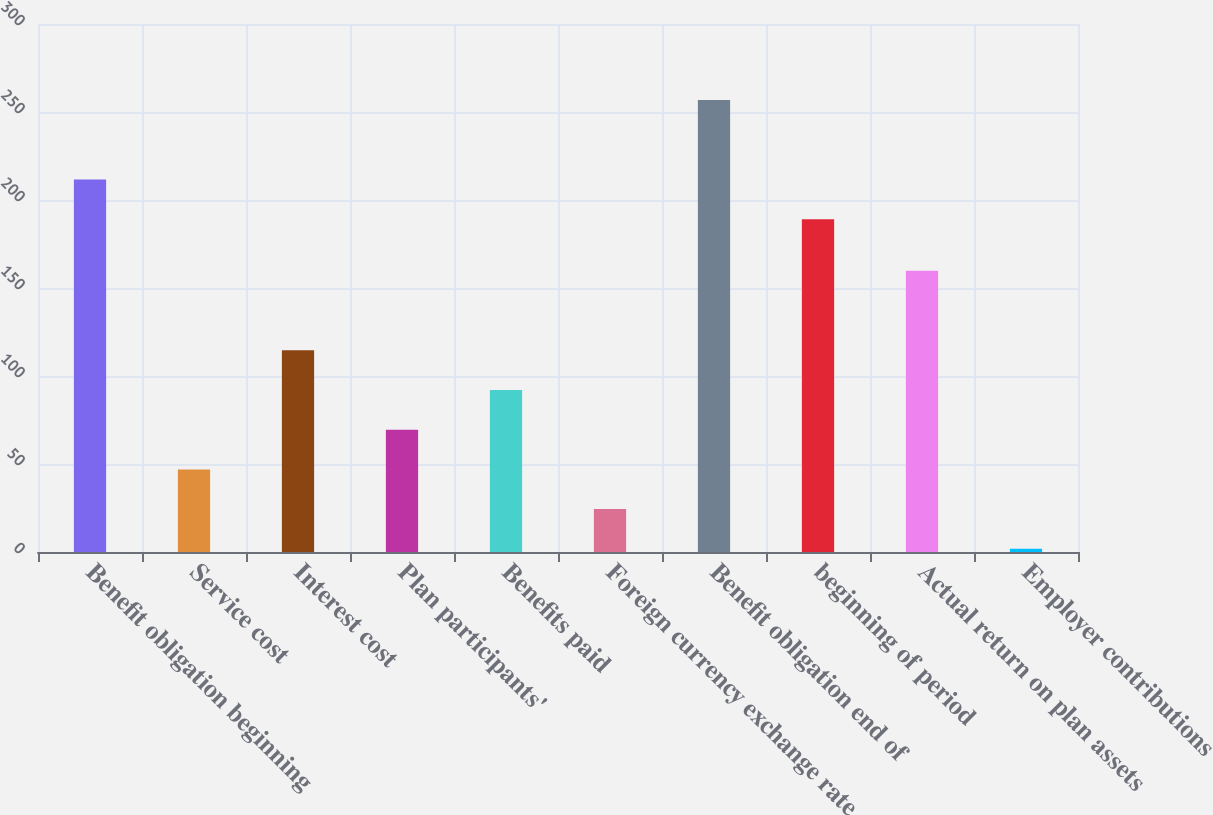Convert chart to OTSL. <chart><loc_0><loc_0><loc_500><loc_500><bar_chart><fcel>Benefit obligation beginning<fcel>Service cost<fcel>Interest cost<fcel>Plan participants'<fcel>Benefits paid<fcel>Foreign currency exchange rate<fcel>Benefit obligation end of<fcel>beginning of period<fcel>Actual return on plan assets<fcel>Employer contributions<nl><fcel>211.67<fcel>46.94<fcel>114.65<fcel>69.51<fcel>92.08<fcel>24.37<fcel>256.81<fcel>189.1<fcel>159.79<fcel>1.8<nl></chart> 